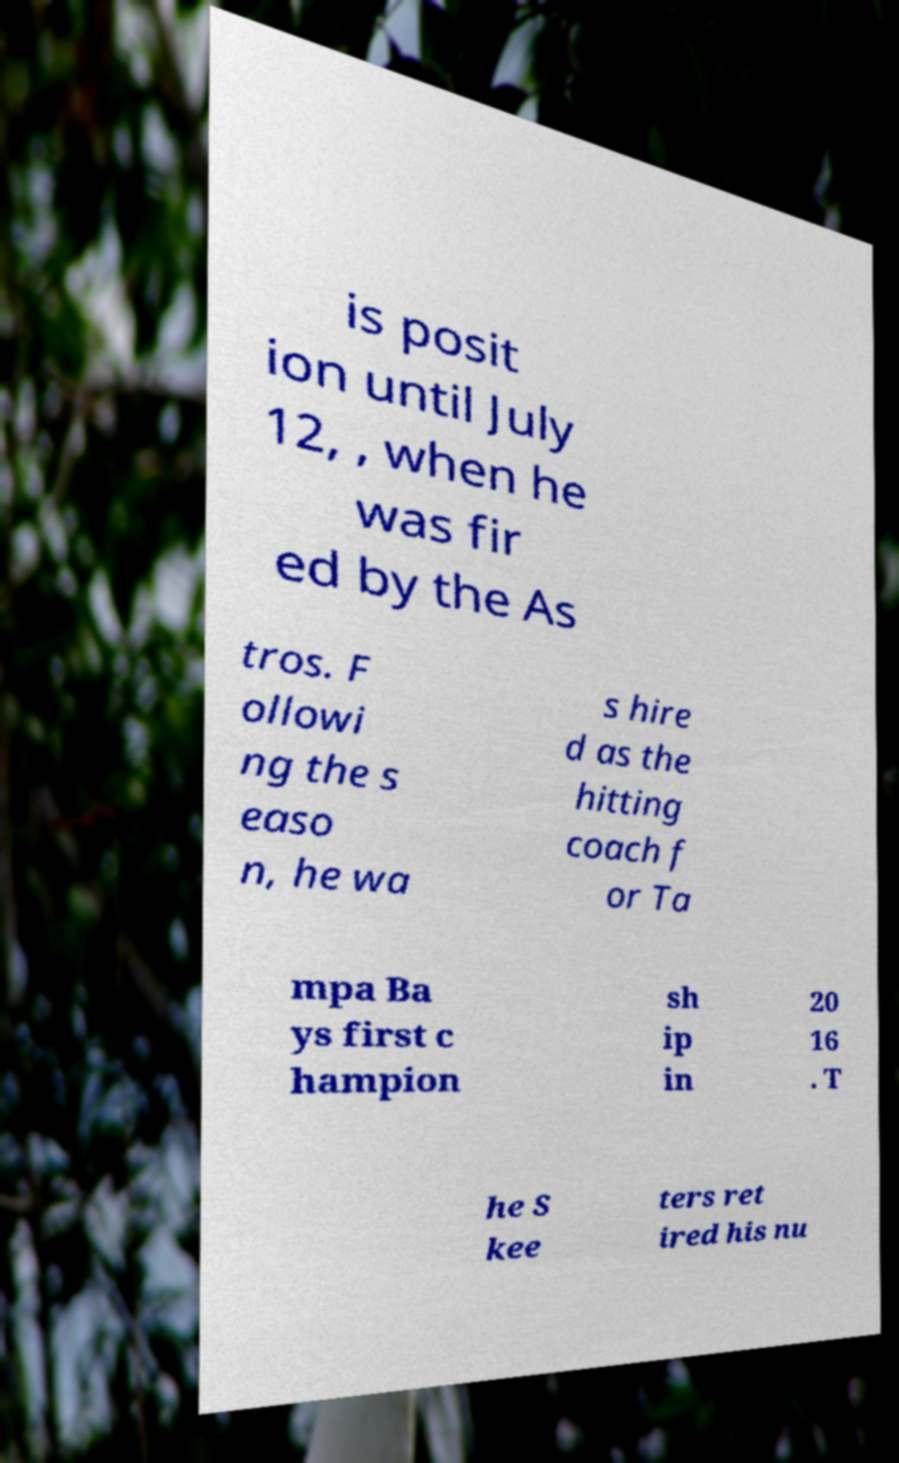There's text embedded in this image that I need extracted. Can you transcribe it verbatim? is posit ion until July 12, , when he was fir ed by the As tros. F ollowi ng the s easo n, he wa s hire d as the hitting coach f or Ta mpa Ba ys first c hampion sh ip in 20 16 . T he S kee ters ret ired his nu 